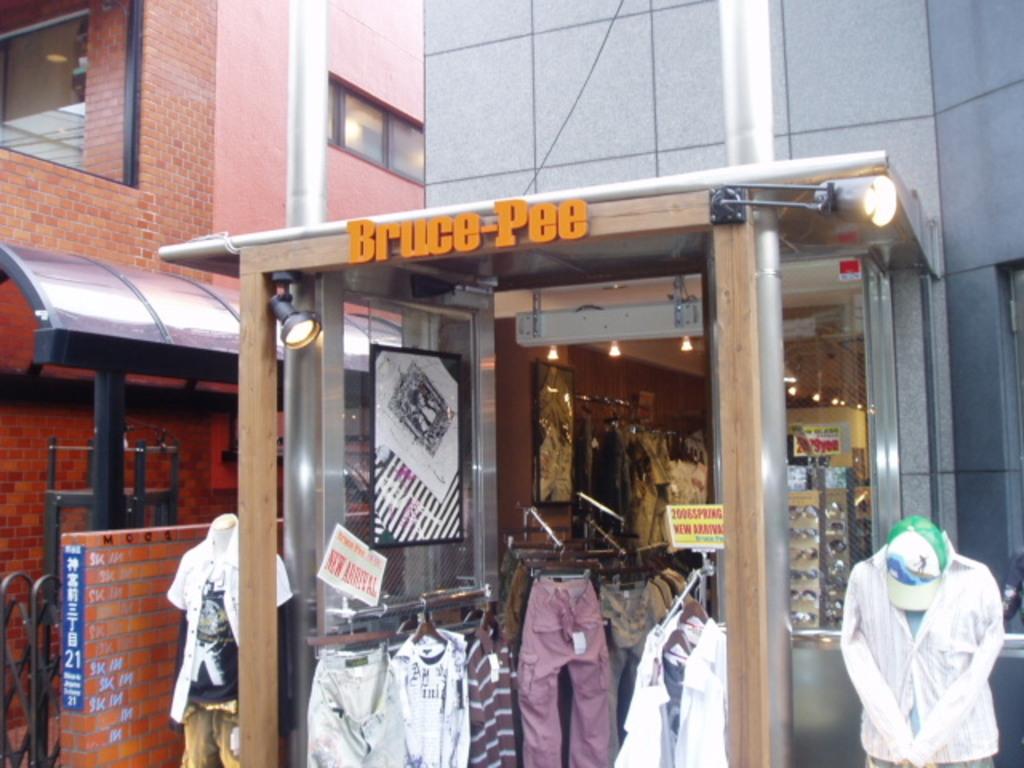What is the store's name?
Make the answer very short. Bruce pee. 